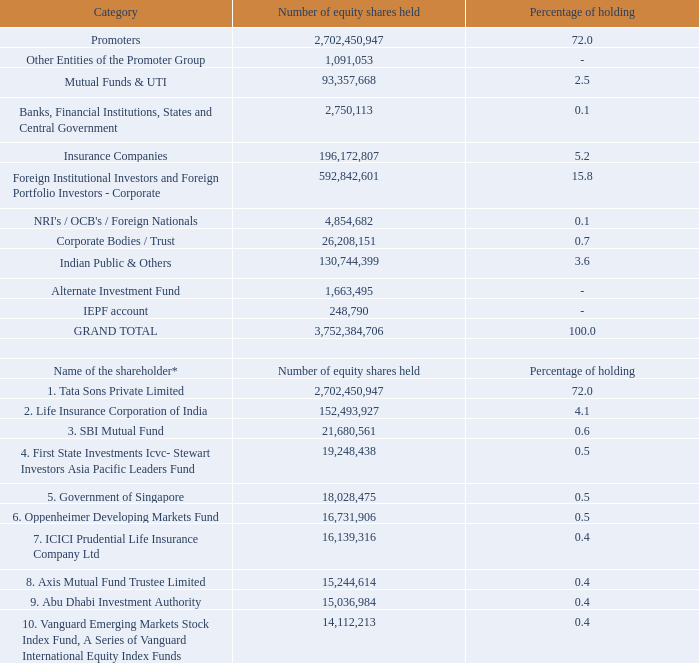B. categories of equity shareholding as on march 31, 2019:
c. top ten equity shareholders of the company as on march 31, 2019:
* shareholding is consolidated based on permanent account number (pan) of the shareholder.
who is the majority shareholder?  Tata sons private limited. How many equity shares does the Government of Singapore hold in the company? 18,028,475. What percentage shareholding does the majority shareholder have? 
Answer scale should be: percent. 72. What is the difference in percentage shareholding between Tata Sons Private Limited and Life Insurance Corporation of India?
Answer scale should be: percent. 72-4.1 
Answer: 67.9. What is the difference in number of equity shares held between ICICI Prudential Life Insurance and Axis Mutual Fund Trustee? 16,139,316-15,244,614 
Answer: 894702. What is the difference between number of equity shares held between Promoters and Insurance Companies? 2,702,450,947-196,172,807 
Answer: 2506278140. 